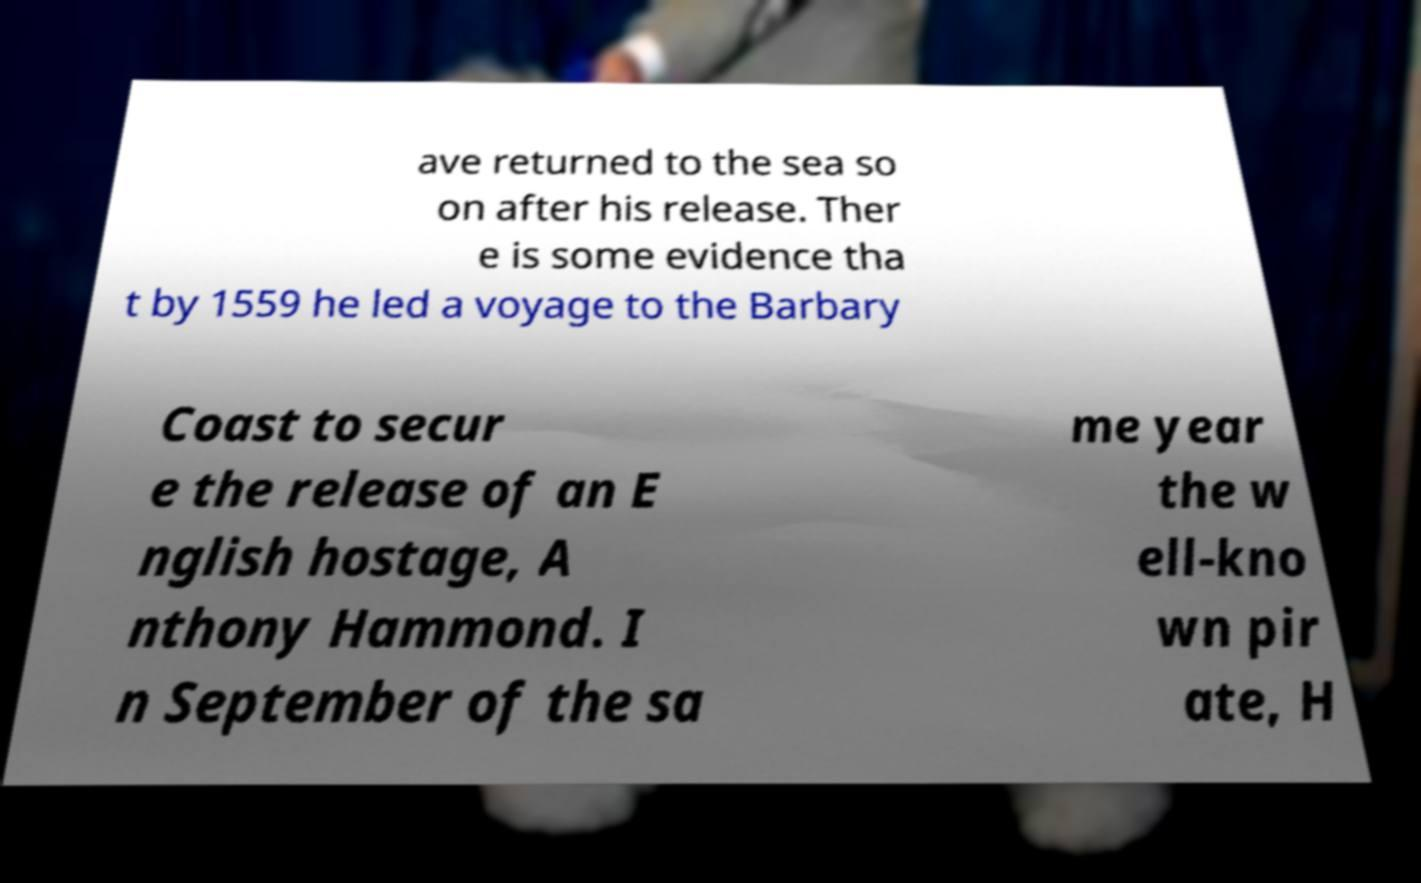Could you assist in decoding the text presented in this image and type it out clearly? ave returned to the sea so on after his release. Ther e is some evidence tha t by 1559 he led a voyage to the Barbary Coast to secur e the release of an E nglish hostage, A nthony Hammond. I n September of the sa me year the w ell-kno wn pir ate, H 